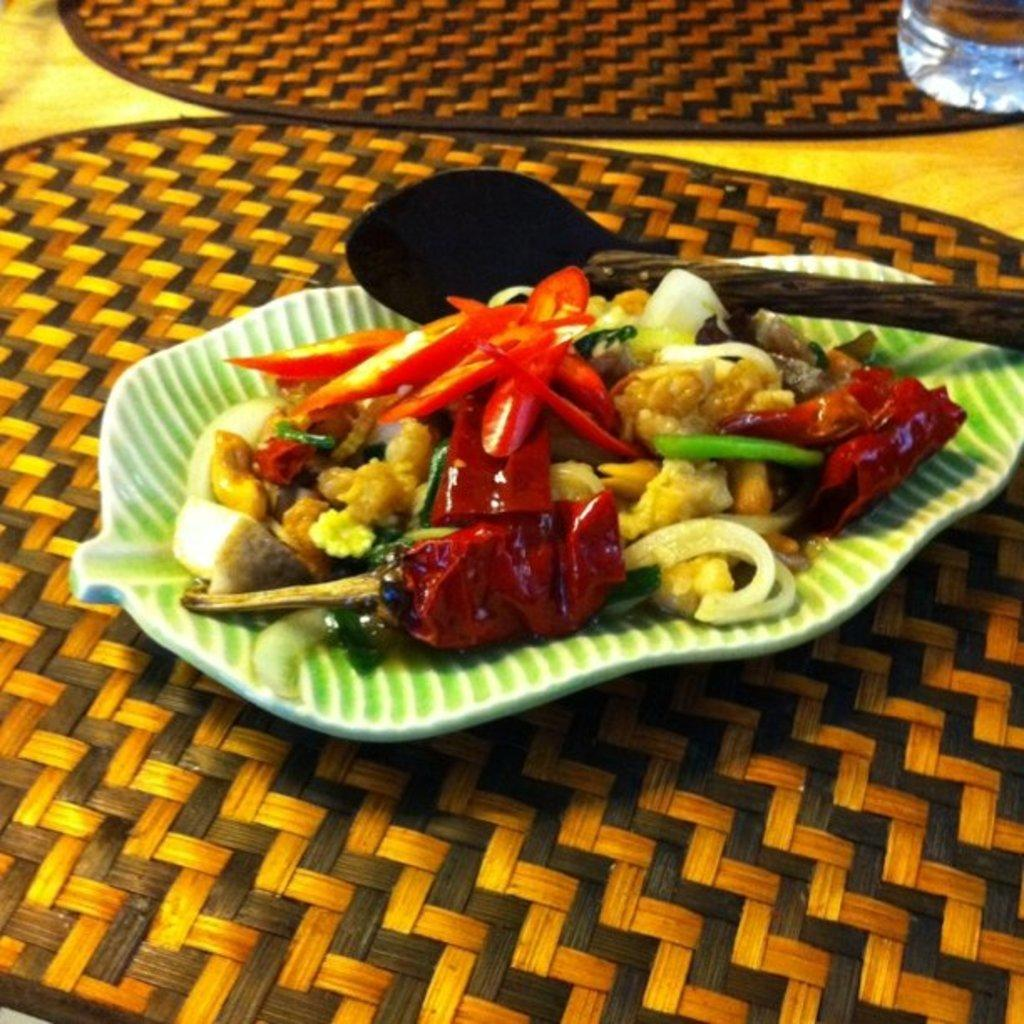What is on the plate in the image? There is a food item on a plate in the image. What utensil is present with the food item? A spoon is present with the food item. Where is the plate placed in the image? The plate is placed on a table mat. Can you describe another mat in the image? There is another mat in the image. What might be used for drinking in the image? There appears to be a glass of water in the top right corner of the image. What type of fact is the minister discussing with the pest in the image? There is no minister or pest present in the image; it features a plate with a food item, a spoon, a table mat, another mat, and a glass of water. 